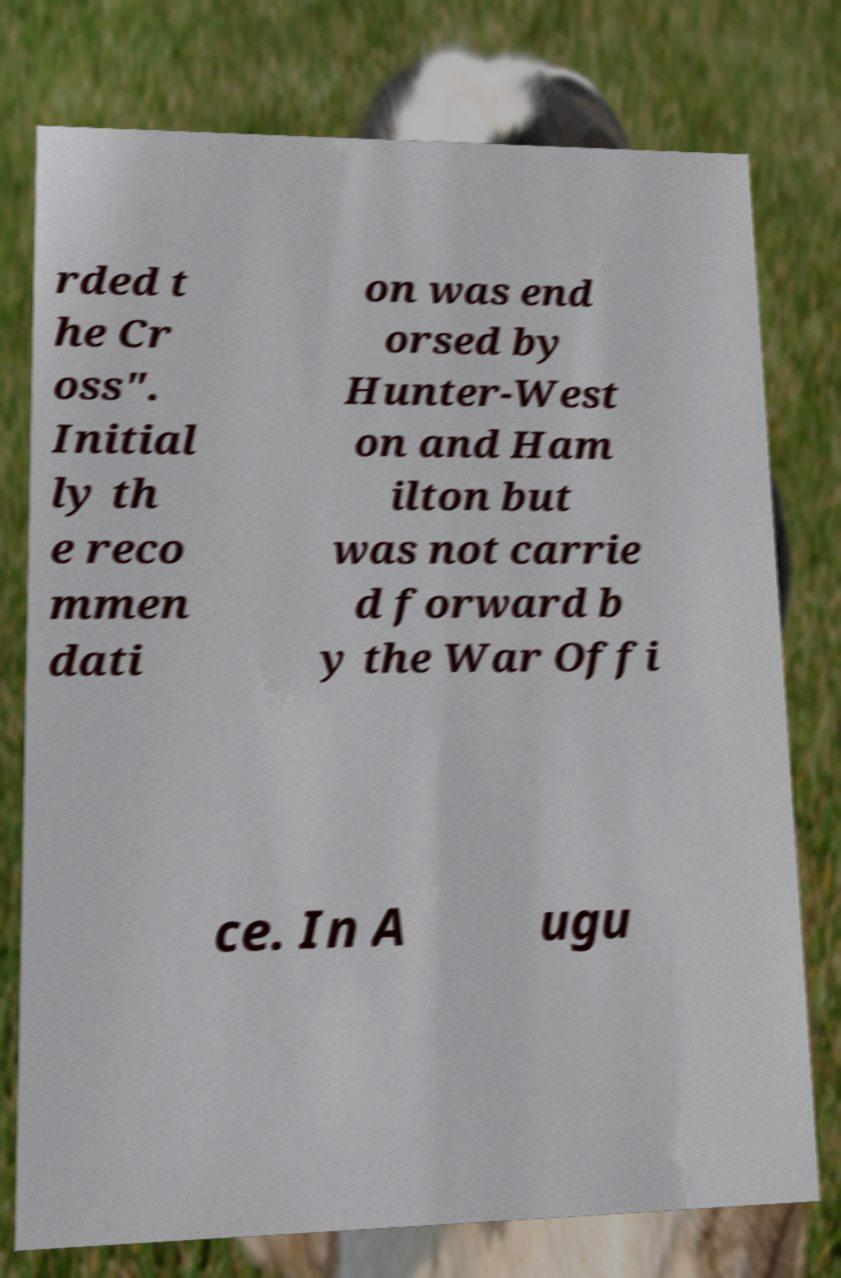Could you extract and type out the text from this image? rded t he Cr oss". Initial ly th e reco mmen dati on was end orsed by Hunter-West on and Ham ilton but was not carrie d forward b y the War Offi ce. In A ugu 